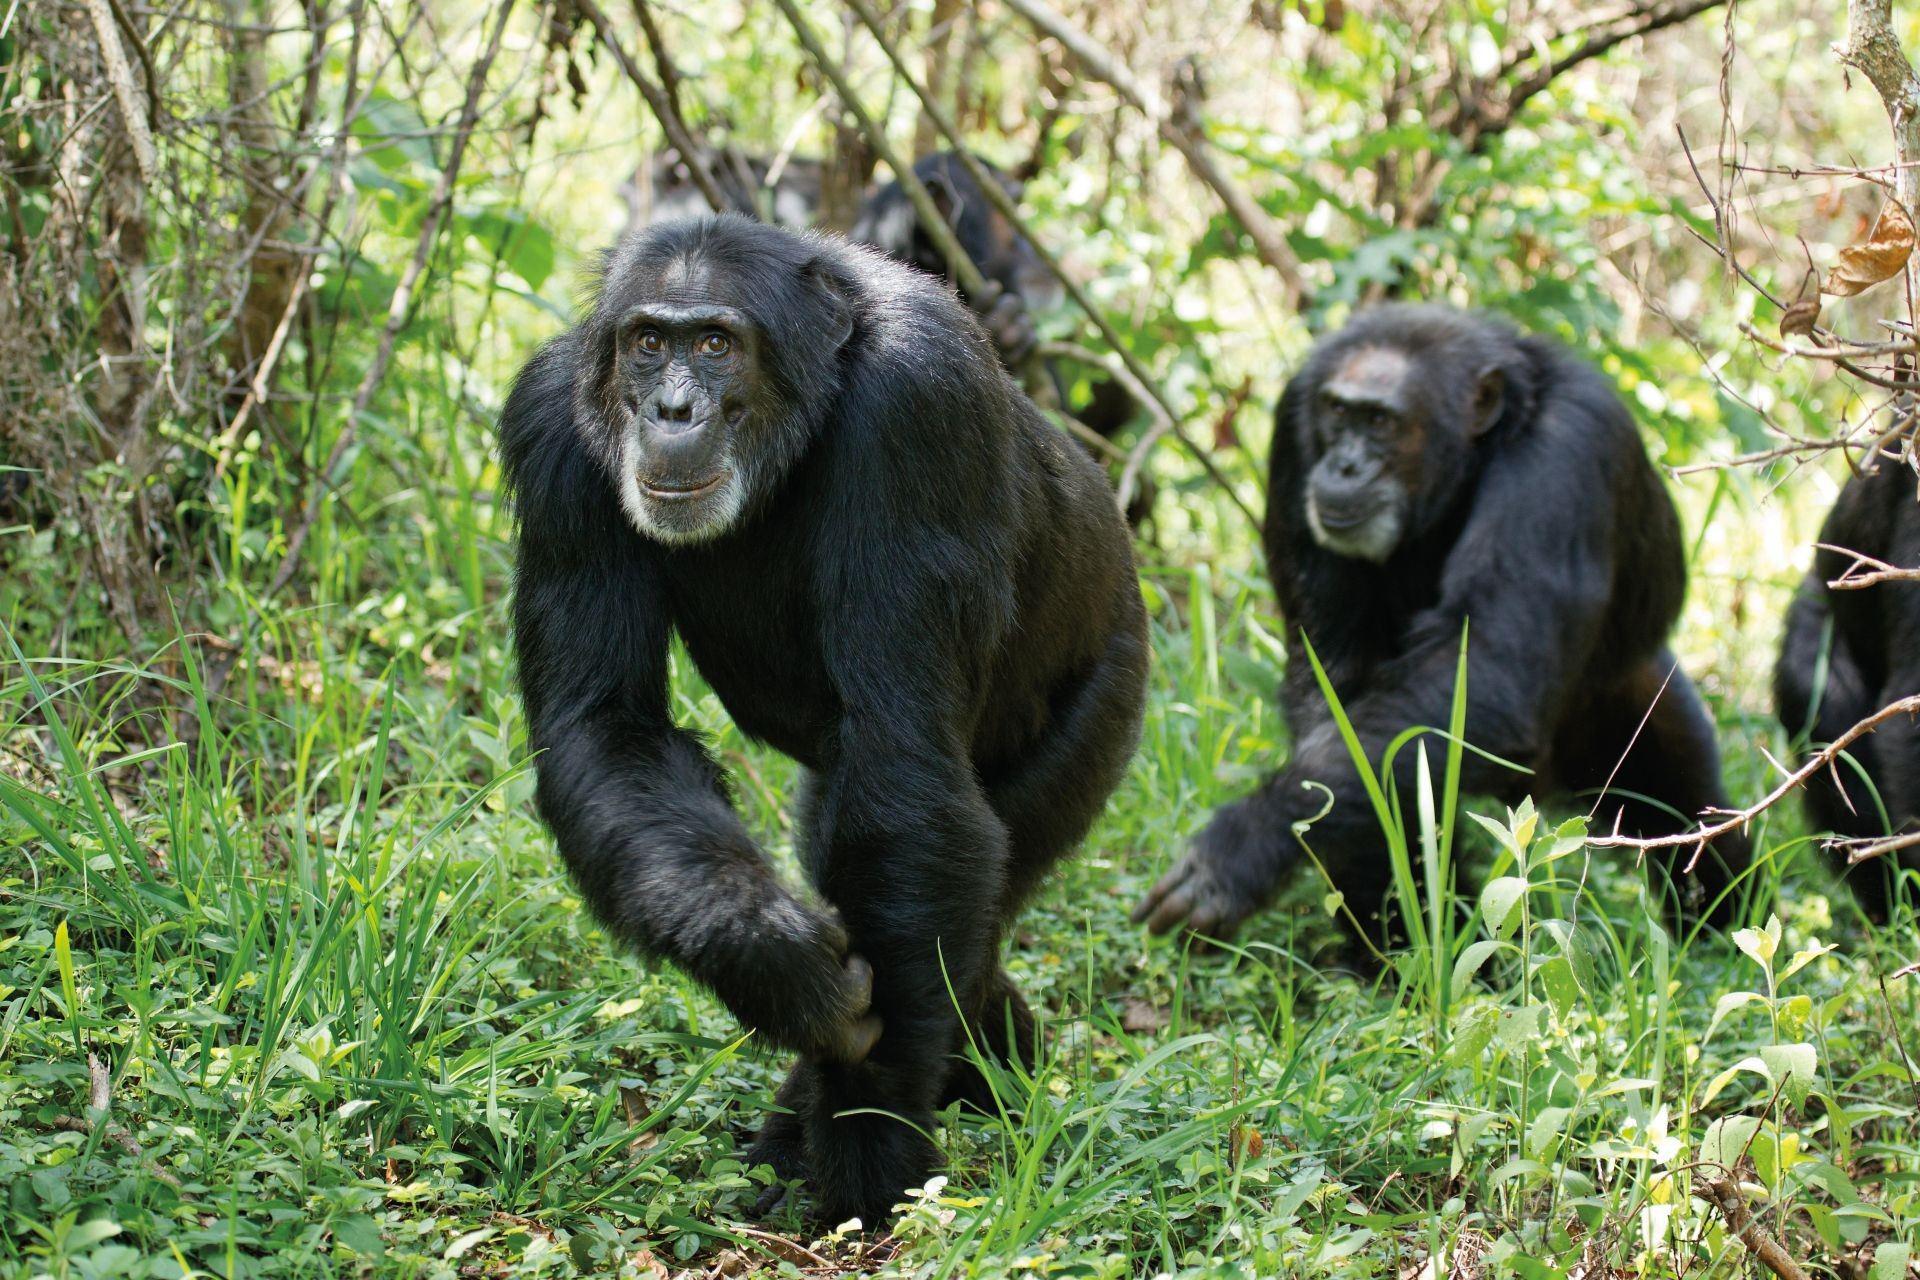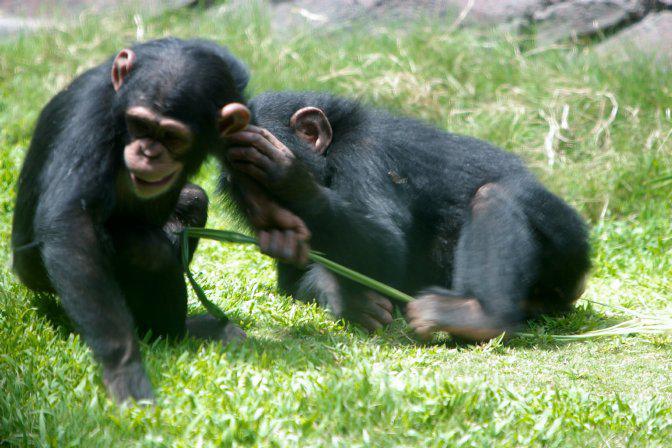The first image is the image on the left, the second image is the image on the right. Examine the images to the left and right. Is the description "An image includes at least one chimp sitting behind another chimp and grooming its fur." accurate? Answer yes or no. No. The first image is the image on the left, the second image is the image on the right. For the images shown, is this caption "At least one primate in one of the images is sitting on a branch." true? Answer yes or no. No. 